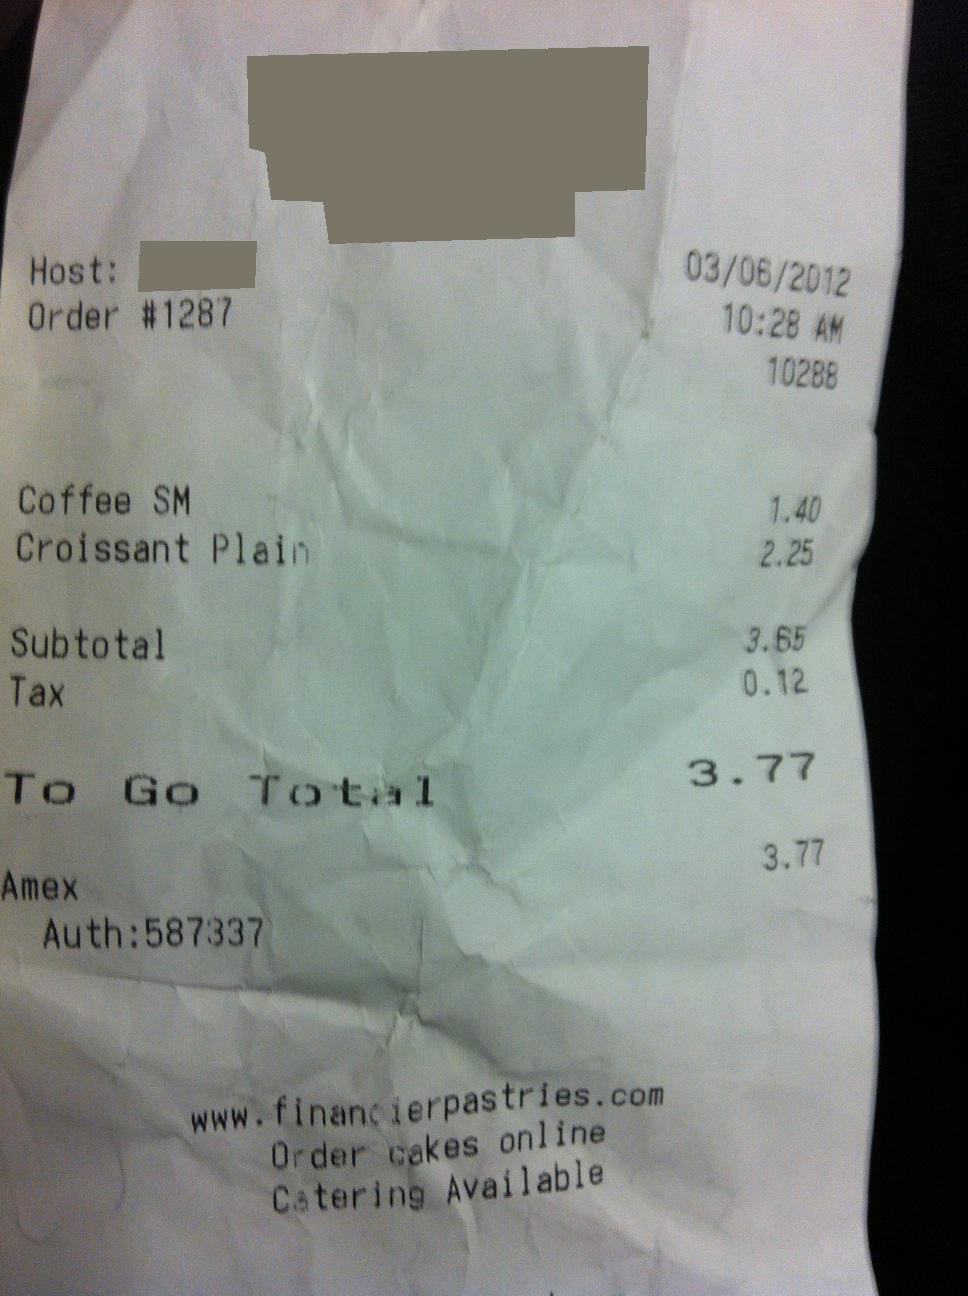How much is the total? from Vizwiz 3.77 